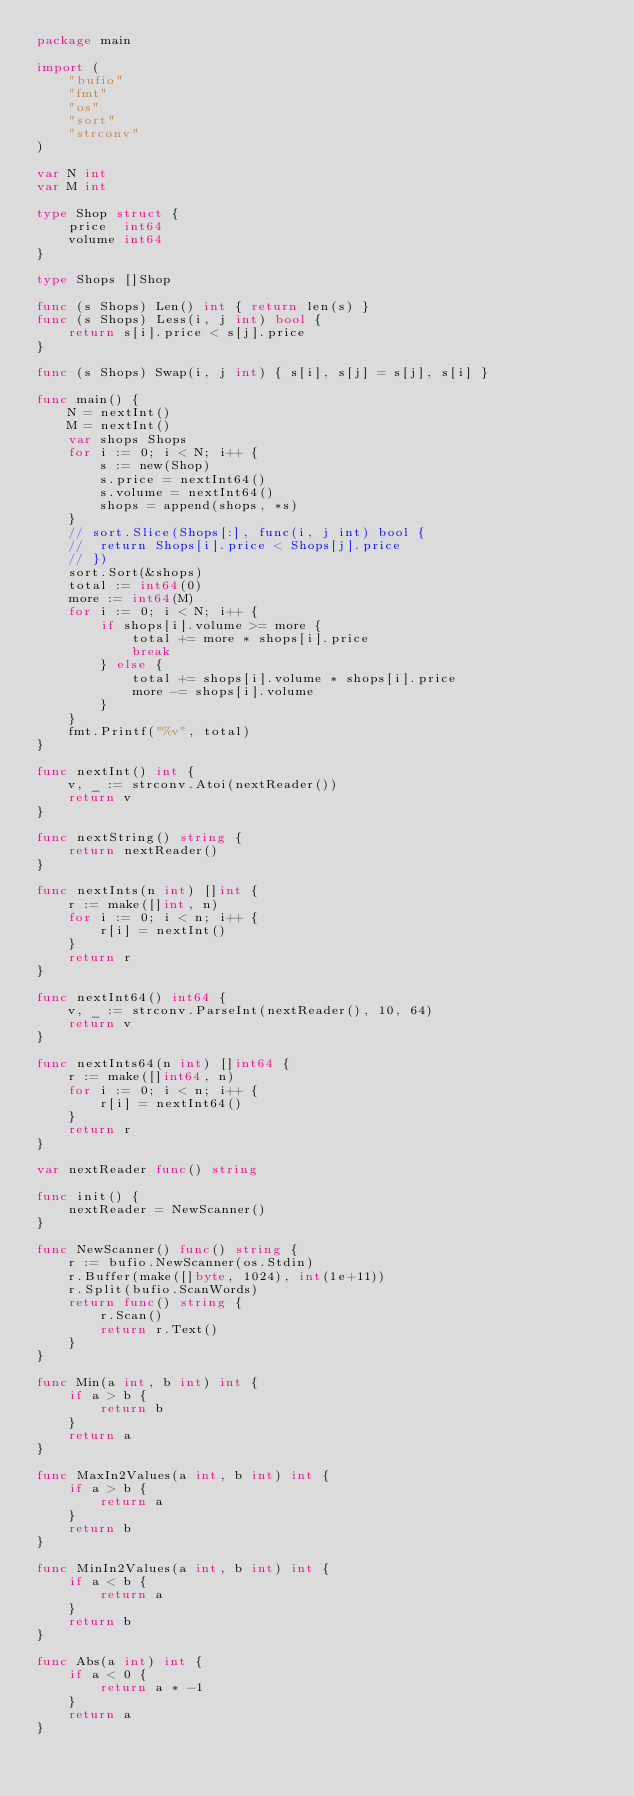<code> <loc_0><loc_0><loc_500><loc_500><_Go_>package main

import (
	"bufio"
	"fmt"
	"os"
	"sort"
	"strconv"
)

var N int
var M int

type Shop struct {
	price  int64
	volume int64
}

type Shops []Shop

func (s Shops) Len() int { return len(s) }
func (s Shops) Less(i, j int) bool {
	return s[i].price < s[j].price
}

func (s Shops) Swap(i, j int) { s[i], s[j] = s[j], s[i] }

func main() {
	N = nextInt()
	M = nextInt()
	var shops Shops
	for i := 0; i < N; i++ {
		s := new(Shop)
		s.price = nextInt64()
		s.volume = nextInt64()
		shops = append(shops, *s)
	}
	// sort.Slice(Shops[:], func(i, j int) bool {
	// 	return Shops[i].price < Shops[j].price
	// })
	sort.Sort(&shops)
	total := int64(0)
	more := int64(M)
	for i := 0; i < N; i++ {
		if shops[i].volume >= more {
			total += more * shops[i].price
			break
		} else {
			total += shops[i].volume * shops[i].price
			more -= shops[i].volume
		}
	}
	fmt.Printf("%v", total)
}

func nextInt() int {
	v, _ := strconv.Atoi(nextReader())
	return v
}

func nextString() string {
	return nextReader()
}

func nextInts(n int) []int {
	r := make([]int, n)
	for i := 0; i < n; i++ {
		r[i] = nextInt()
	}
	return r
}

func nextInt64() int64 {
	v, _ := strconv.ParseInt(nextReader(), 10, 64)
	return v
}

func nextInts64(n int) []int64 {
	r := make([]int64, n)
	for i := 0; i < n; i++ {
		r[i] = nextInt64()
	}
	return r
}

var nextReader func() string

func init() {
	nextReader = NewScanner()
}

func NewScanner() func() string {
	r := bufio.NewScanner(os.Stdin)
	r.Buffer(make([]byte, 1024), int(1e+11))
	r.Split(bufio.ScanWords)
	return func() string {
		r.Scan()
		return r.Text()
	}
}

func Min(a int, b int) int {
	if a > b {
		return b
	}
	return a
}

func MaxIn2Values(a int, b int) int {
	if a > b {
		return a
	}
	return b
}

func MinIn2Values(a int, b int) int {
	if a < b {
		return a
	}
	return b
}

func Abs(a int) int {
	if a < 0 {
		return a * -1
	}
	return a
}
</code> 